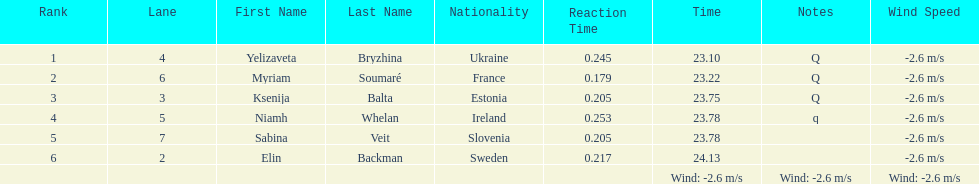The difference between yelizaveta bryzhina's time and ksenija balta's time? 0.65. 